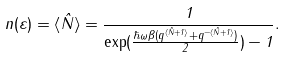<formula> <loc_0><loc_0><loc_500><loc_500>n ( \varepsilon ) = { \langle } \hat { N } { \rangle } = \frac { 1 } { \exp ( \frac { \hbar { \omega } \beta ( q ^ { { \langle } \hat { N } + 1 { \rangle } } + q ^ { - { \langle } \hat { N } + 1 { \rangle } } ) } { 2 } ) - 1 } .</formula> 